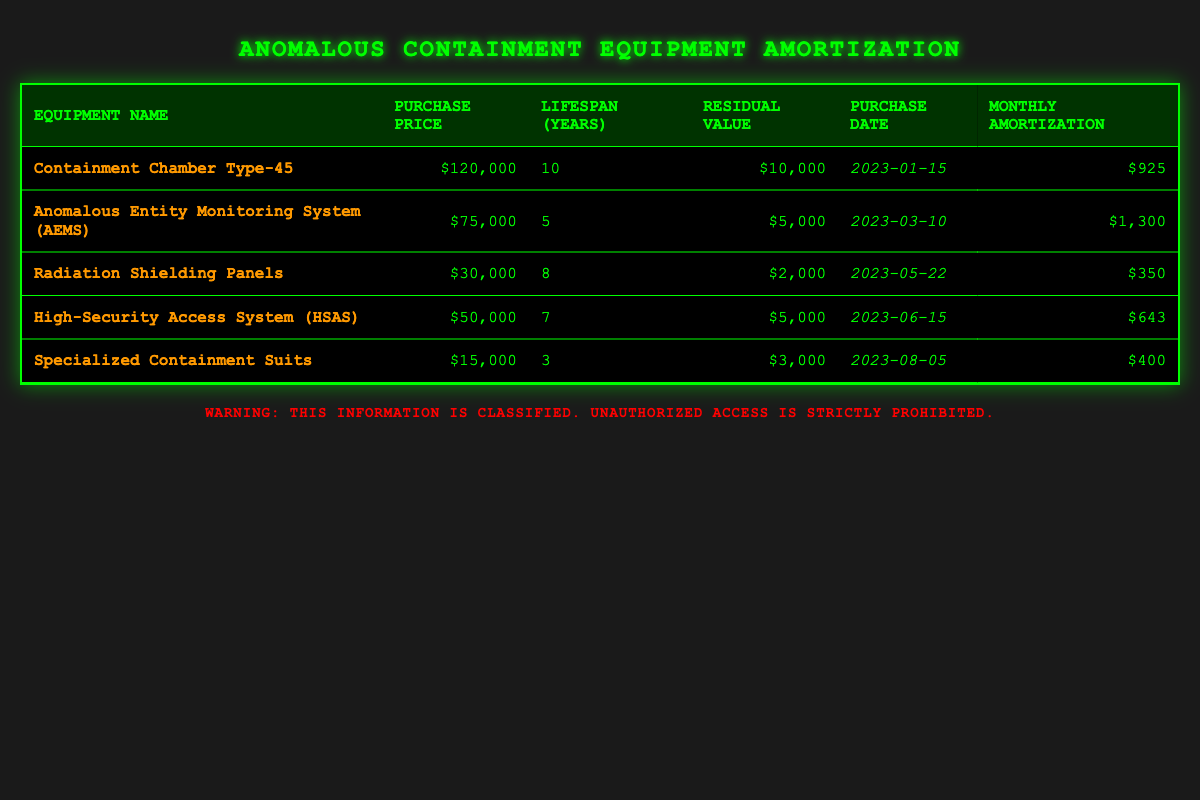What is the purchase price of the Containment Chamber Type-45? The purchase price for the Containment Chamber Type-45 is explicitly listed in the table under the "Purchase Price" column as $120,000.
Answer: $120,000 How many years is the lifespan of the Anomalous Entity Monitoring System (AEMS)? The lifespan of the Anomalous Entity Monitoring System (AEMS) is provided in the table under the "Lifespan (Years)" column. It shows a lifespan of 5 years.
Answer: 5 years What is the total monthly amortization for all equipment listed? To find the total monthly amortization, I sum the monthly amortization amounts from each equipment row: 925 + 1300 + 350 + 643 + 400 = 3628. The total monthly amortization is therefore $3,628.
Answer: $3,628 Is the residual value of the Radiation Shielding Panels greater than $1,500? The residual value of the Radiation Shielding Panels is listed as $2,000 in the table. Since $2,000 is greater than $1,500, the answer to this question is yes.
Answer: Yes What is the average purchase price of all the equipment? To find the average purchase price, I first calculate the sum of the purchase prices: 120000 + 75000 + 30000 + 50000 + 15000 = 300000. There are 5 pieces of equipment, so the average purchase price is 300000 / 5 = 60000.
Answer: $60,000 What is the difference in monthly amortization between the Anomalous Entity Monitoring System and Specialized Containment Suits? The monthly amortization of the Anomalous Entity Monitoring System is $1,300, while the monthly amortization for the Specialized Containment Suits is $400. The difference is calculated as 1300 - 400 = 900.
Answer: $900 Is it true that all equipment has a residual value greater than $2,000? By inspecting the residual values in the table, the Radiation Shielding Panels have a residual value of $2,000, which meets the requirement. However, the Specialized Containment Suits have a value of $3,000. Thus, the statement is true, meaning all equipment has a residual value greater than $2,000.
Answer: Yes Which equipment has the longest lifespan? I check the "Lifespan (Years)" column for all equipment and find that the Containment Chamber Type-45 has the longest lifespan of 10 years, compared to others with 5, 8, 7, and 3 years respectively.
Answer: Containment Chamber Type-45 If the purchase date of the High-Security Access System (HSAS) was 6 months earlier, would it have changed its age? The purchase date of the HSAS is listed as June 15, 2023. If it had been purchased 6 months earlier, it would be December 15, 2022. Since the current date is past June 2023, this equipment's age would be calculated based on its original purchase date of 2023. Thus, changing it to 2022 would indeed change its age.
Answer: Yes 